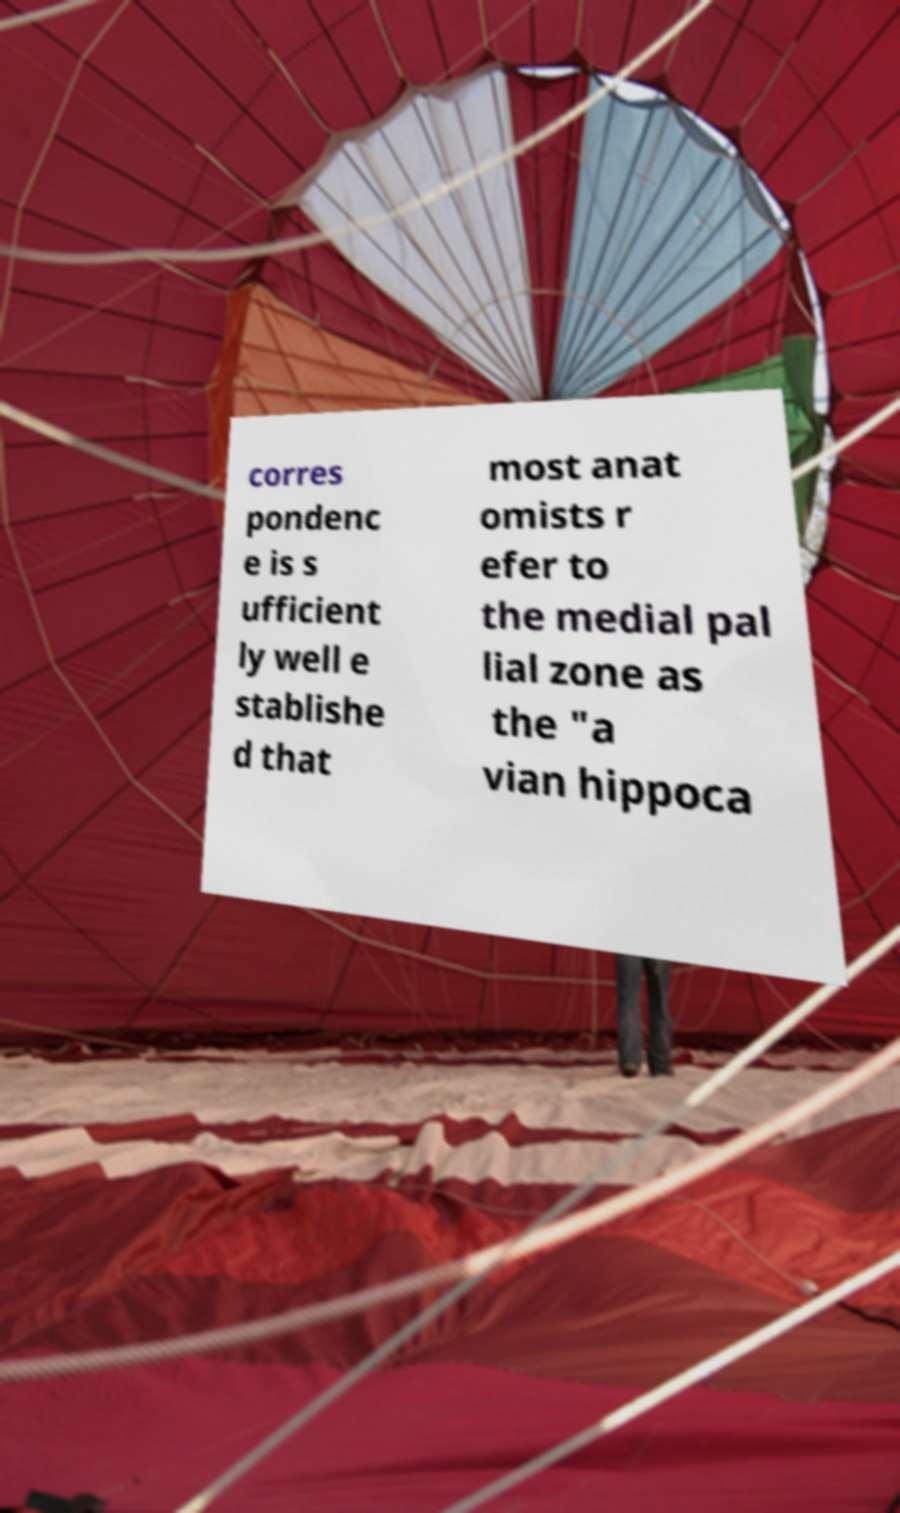Please read and relay the text visible in this image. What does it say? corres pondenc e is s ufficient ly well e stablishe d that most anat omists r efer to the medial pal lial zone as the "a vian hippoca 